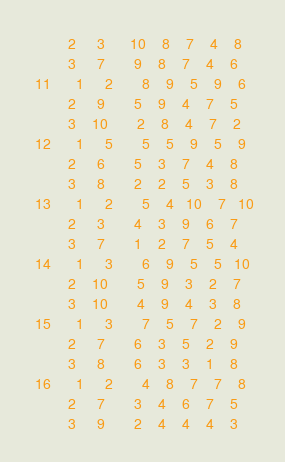<code> <loc_0><loc_0><loc_500><loc_500><_ObjectiveC_>         2     3      10    8    7    4    8
         3     7       9    8    7    4    6
 11      1     2       8    9    5    9    6
         2     9       5    9    4    7    5
         3    10       2    8    4    7    2
 12      1     5       5    5    9    5    9
         2     6       5    3    7    4    8
         3     8       2    2    5    3    8
 13      1     2       5    4   10    7   10
         2     3       4    3    9    6    7
         3     7       1    2    7    5    4
 14      1     3       6    9    5    5   10
         2    10       5    9    3    2    7
         3    10       4    9    4    3    8
 15      1     3       7    5    7    2    9
         2     7       6    3    5    2    9
         3     8       6    3    3    1    8
 16      1     2       4    8    7    7    8
         2     7       3    4    6    7    5
         3     9       2    4    4    4    3</code> 